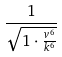<formula> <loc_0><loc_0><loc_500><loc_500>\frac { 1 } { \sqrt { 1 \cdot \frac { v ^ { 6 } } { k ^ { 6 } } } }</formula> 